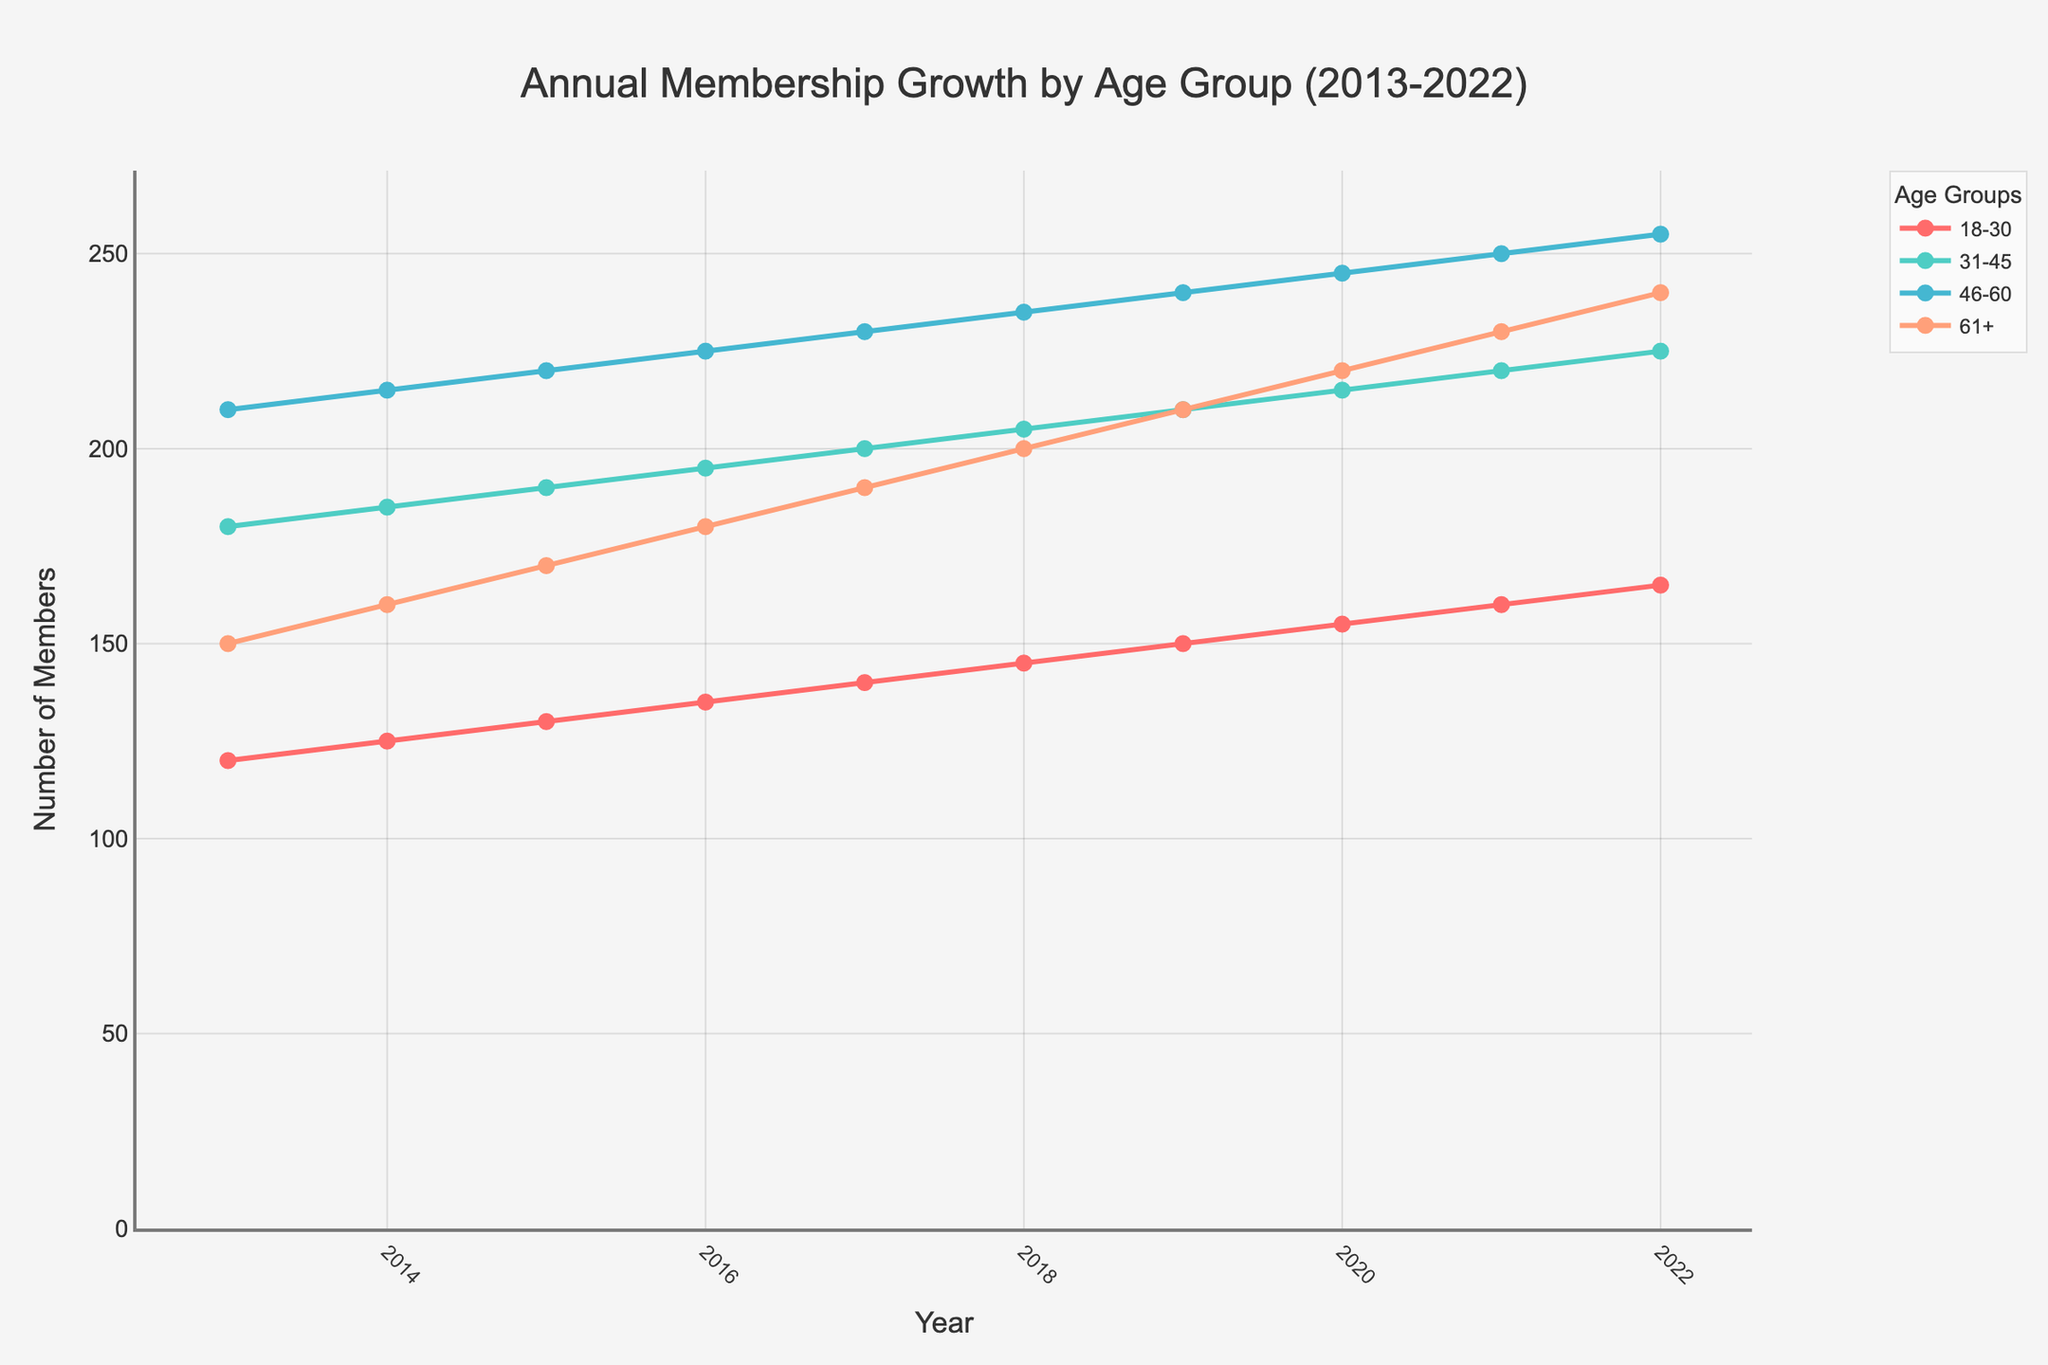What's the total membership growth in the 18-30 age group from 2013 to 2022? Check the initial and final values for the 18-30 age group, which are 120 in 2013 and 165 in 2022. Calculate the difference: 165 - 120
Answer: 45 Which age group had the largest membership in 2022? Compare the values of all age groups in 2022: 18-30 has 165, 31-45 has 225, 46-60 has 255, and 61+ has 240. The largest is 46-60 with 255 members
Answer: 46-60 How did the membership in the 61+ age group change between 2015 and 2019? Check the values for the 61+ age group: 170 in 2015 and 210 in 2019. Calculate the difference: 210 - 170
Answer: 40 Which age group saw the smallest increase in members from 2013 to 2022? Calculate the differences for all groups: 18-30 (165-120=45), 31-45 (225-180=45), 46-60 (255-210=45), 61+ (240-150=90). The smallest increase is shared by 18-30, 31-45, and 46-60 with a 45-member increase
Answer: 18-30, 31-45, 46-60 In which year did the 18-30 age group surpass 150 members? Check the values for the 18-30 age group and find the first year with more than 150 members, which was in 2019
Answer: 2019 Which age group consistently grew each year without any decreases from 2013 to 2022? Review the trends for each age group. 18-30, 31-45, 46-60, and 61+ all show consistent growth without any decreases
Answer: 18-30, 31-45, 46-60, 61+ What is the average annual growth rate of the 31-45 age group over the decade? The initial membership in 2013 was 180 and 225 in 2022. The total increase over 10 years is 225 - 180 = 45. Average annual growth rate is 45 / 10
Answer: 4.5 members per year Which age group had the steepest growth between 2013 and 2022? Calculate the difference for each group: 18-30 (45), 31-45 (45), 46-60 (45), 61+ (90). The steepest growth is in the 61+ age group with an increase of 90 members
Answer: 61+ By how much did membership in the 46-60 age group increase from 2017 to 2021? Check the values for the 46-60 age group: 230 in 2017 and 250 in 2021. Calculate the difference: 250 - 230
Answer: 20 Which year showed the highest total membership across all age groups? Sum the membership of all age groups for each year and compare. The total membership in 2022 is the highest with (165 + 225 + 255 + 240) = 885 members
Answer: 2022 